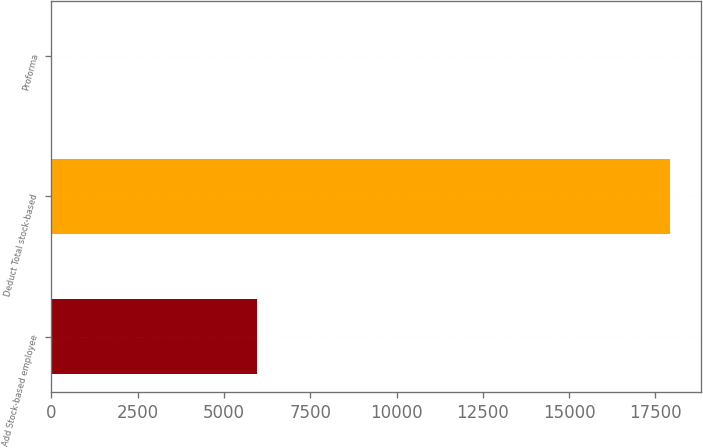Convert chart to OTSL. <chart><loc_0><loc_0><loc_500><loc_500><bar_chart><fcel>Add Stock-based employee<fcel>Deduct Total stock-based<fcel>Proforma<nl><fcel>5956<fcel>17933<fcel>0.05<nl></chart> 